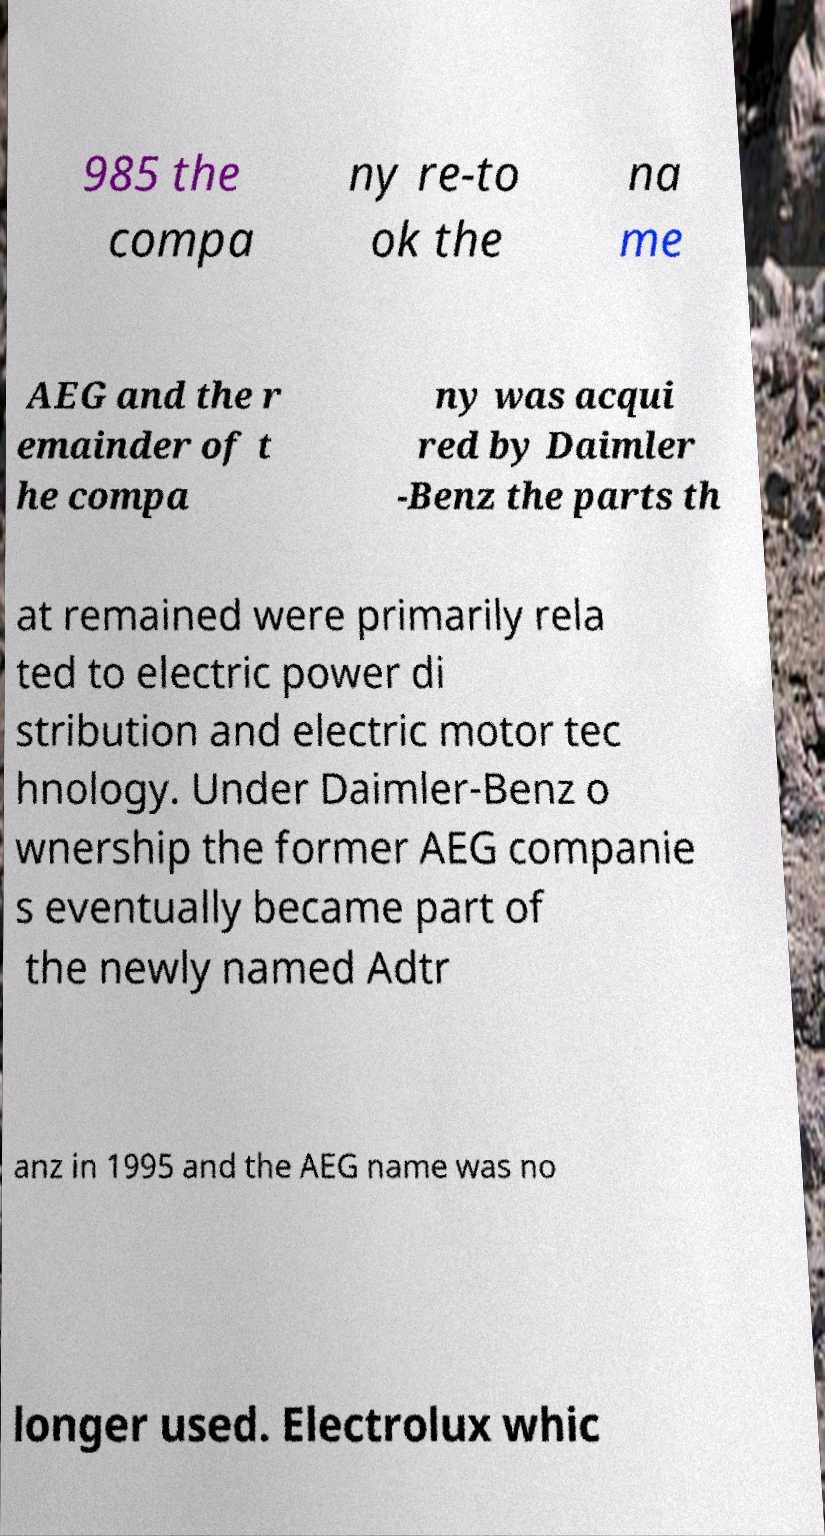Please read and relay the text visible in this image. What does it say? 985 the compa ny re-to ok the na me AEG and the r emainder of t he compa ny was acqui red by Daimler -Benz the parts th at remained were primarily rela ted to electric power di stribution and electric motor tec hnology. Under Daimler-Benz o wnership the former AEG companie s eventually became part of the newly named Adtr anz in 1995 and the AEG name was no longer used. Electrolux whic 